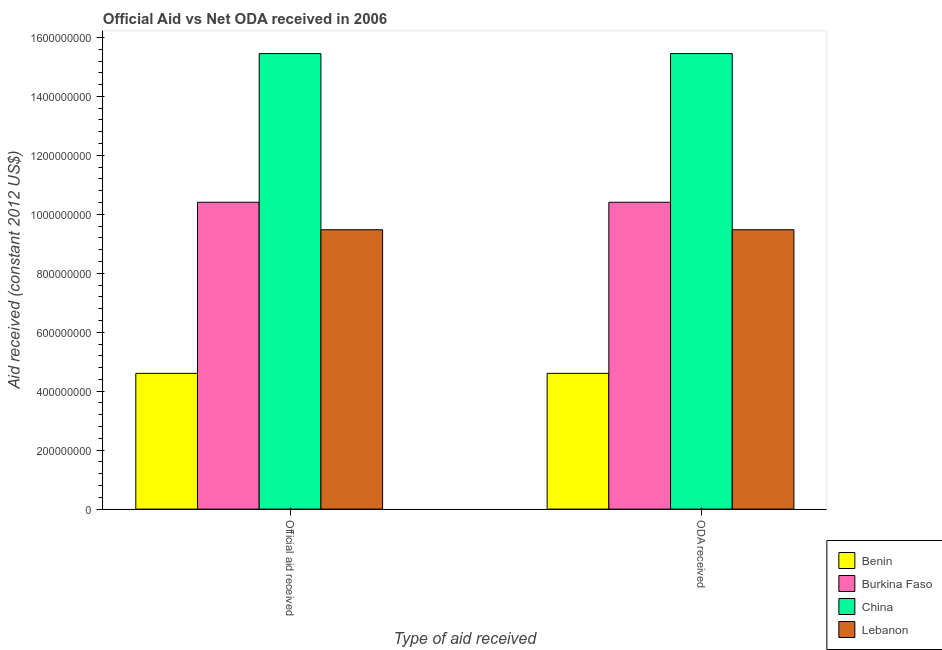How many different coloured bars are there?
Your response must be concise. 4. Are the number of bars per tick equal to the number of legend labels?
Keep it short and to the point. Yes. What is the label of the 1st group of bars from the left?
Your response must be concise. Official aid received. What is the official aid received in Lebanon?
Give a very brief answer. 9.48e+08. Across all countries, what is the maximum oda received?
Your response must be concise. 1.55e+09. Across all countries, what is the minimum oda received?
Give a very brief answer. 4.60e+08. In which country was the official aid received minimum?
Ensure brevity in your answer.  Benin. What is the total official aid received in the graph?
Your response must be concise. 3.99e+09. What is the difference between the official aid received in Benin and that in Lebanon?
Provide a succinct answer. -4.87e+08. What is the difference between the official aid received in Burkina Faso and the oda received in Lebanon?
Give a very brief answer. 9.31e+07. What is the average oda received per country?
Ensure brevity in your answer.  9.98e+08. What is the ratio of the oda received in Burkina Faso to that in Lebanon?
Offer a terse response. 1.1. In how many countries, is the official aid received greater than the average official aid received taken over all countries?
Your response must be concise. 2. What does the 1st bar from the left in ODA received represents?
Give a very brief answer. Benin. What does the 3rd bar from the right in ODA received represents?
Offer a very short reply. Burkina Faso. Does the graph contain any zero values?
Provide a short and direct response. No. Where does the legend appear in the graph?
Keep it short and to the point. Bottom right. How many legend labels are there?
Your answer should be very brief. 4. How are the legend labels stacked?
Ensure brevity in your answer.  Vertical. What is the title of the graph?
Offer a terse response. Official Aid vs Net ODA received in 2006 . What is the label or title of the X-axis?
Offer a terse response. Type of aid received. What is the label or title of the Y-axis?
Keep it short and to the point. Aid received (constant 2012 US$). What is the Aid received (constant 2012 US$) of Benin in Official aid received?
Ensure brevity in your answer.  4.60e+08. What is the Aid received (constant 2012 US$) of Burkina Faso in Official aid received?
Provide a short and direct response. 1.04e+09. What is the Aid received (constant 2012 US$) of China in Official aid received?
Offer a very short reply. 1.55e+09. What is the Aid received (constant 2012 US$) of Lebanon in Official aid received?
Provide a succinct answer. 9.48e+08. What is the Aid received (constant 2012 US$) in Benin in ODA received?
Your answer should be compact. 4.60e+08. What is the Aid received (constant 2012 US$) of Burkina Faso in ODA received?
Keep it short and to the point. 1.04e+09. What is the Aid received (constant 2012 US$) in China in ODA received?
Your answer should be very brief. 1.55e+09. What is the Aid received (constant 2012 US$) of Lebanon in ODA received?
Ensure brevity in your answer.  9.48e+08. Across all Type of aid received, what is the maximum Aid received (constant 2012 US$) in Benin?
Your response must be concise. 4.60e+08. Across all Type of aid received, what is the maximum Aid received (constant 2012 US$) in Burkina Faso?
Your response must be concise. 1.04e+09. Across all Type of aid received, what is the maximum Aid received (constant 2012 US$) of China?
Your answer should be very brief. 1.55e+09. Across all Type of aid received, what is the maximum Aid received (constant 2012 US$) in Lebanon?
Make the answer very short. 9.48e+08. Across all Type of aid received, what is the minimum Aid received (constant 2012 US$) in Benin?
Your answer should be very brief. 4.60e+08. Across all Type of aid received, what is the minimum Aid received (constant 2012 US$) in Burkina Faso?
Provide a succinct answer. 1.04e+09. Across all Type of aid received, what is the minimum Aid received (constant 2012 US$) in China?
Keep it short and to the point. 1.55e+09. Across all Type of aid received, what is the minimum Aid received (constant 2012 US$) of Lebanon?
Ensure brevity in your answer.  9.48e+08. What is the total Aid received (constant 2012 US$) in Benin in the graph?
Provide a succinct answer. 9.21e+08. What is the total Aid received (constant 2012 US$) of Burkina Faso in the graph?
Offer a terse response. 2.08e+09. What is the total Aid received (constant 2012 US$) of China in the graph?
Make the answer very short. 3.09e+09. What is the total Aid received (constant 2012 US$) of Lebanon in the graph?
Provide a short and direct response. 1.90e+09. What is the difference between the Aid received (constant 2012 US$) of Benin in Official aid received and that in ODA received?
Offer a terse response. 0. What is the difference between the Aid received (constant 2012 US$) in Benin in Official aid received and the Aid received (constant 2012 US$) in Burkina Faso in ODA received?
Keep it short and to the point. -5.80e+08. What is the difference between the Aid received (constant 2012 US$) of Benin in Official aid received and the Aid received (constant 2012 US$) of China in ODA received?
Your answer should be compact. -1.08e+09. What is the difference between the Aid received (constant 2012 US$) in Benin in Official aid received and the Aid received (constant 2012 US$) in Lebanon in ODA received?
Provide a succinct answer. -4.87e+08. What is the difference between the Aid received (constant 2012 US$) of Burkina Faso in Official aid received and the Aid received (constant 2012 US$) of China in ODA received?
Offer a terse response. -5.04e+08. What is the difference between the Aid received (constant 2012 US$) in Burkina Faso in Official aid received and the Aid received (constant 2012 US$) in Lebanon in ODA received?
Your answer should be compact. 9.31e+07. What is the difference between the Aid received (constant 2012 US$) in China in Official aid received and the Aid received (constant 2012 US$) in Lebanon in ODA received?
Ensure brevity in your answer.  5.97e+08. What is the average Aid received (constant 2012 US$) of Benin per Type of aid received?
Keep it short and to the point. 4.60e+08. What is the average Aid received (constant 2012 US$) in Burkina Faso per Type of aid received?
Provide a short and direct response. 1.04e+09. What is the average Aid received (constant 2012 US$) in China per Type of aid received?
Ensure brevity in your answer.  1.55e+09. What is the average Aid received (constant 2012 US$) in Lebanon per Type of aid received?
Provide a short and direct response. 9.48e+08. What is the difference between the Aid received (constant 2012 US$) of Benin and Aid received (constant 2012 US$) of Burkina Faso in Official aid received?
Offer a very short reply. -5.80e+08. What is the difference between the Aid received (constant 2012 US$) in Benin and Aid received (constant 2012 US$) in China in Official aid received?
Give a very brief answer. -1.08e+09. What is the difference between the Aid received (constant 2012 US$) in Benin and Aid received (constant 2012 US$) in Lebanon in Official aid received?
Your answer should be compact. -4.87e+08. What is the difference between the Aid received (constant 2012 US$) in Burkina Faso and Aid received (constant 2012 US$) in China in Official aid received?
Your answer should be very brief. -5.04e+08. What is the difference between the Aid received (constant 2012 US$) of Burkina Faso and Aid received (constant 2012 US$) of Lebanon in Official aid received?
Make the answer very short. 9.31e+07. What is the difference between the Aid received (constant 2012 US$) of China and Aid received (constant 2012 US$) of Lebanon in Official aid received?
Your response must be concise. 5.97e+08. What is the difference between the Aid received (constant 2012 US$) of Benin and Aid received (constant 2012 US$) of Burkina Faso in ODA received?
Provide a succinct answer. -5.80e+08. What is the difference between the Aid received (constant 2012 US$) in Benin and Aid received (constant 2012 US$) in China in ODA received?
Provide a short and direct response. -1.08e+09. What is the difference between the Aid received (constant 2012 US$) in Benin and Aid received (constant 2012 US$) in Lebanon in ODA received?
Give a very brief answer. -4.87e+08. What is the difference between the Aid received (constant 2012 US$) in Burkina Faso and Aid received (constant 2012 US$) in China in ODA received?
Keep it short and to the point. -5.04e+08. What is the difference between the Aid received (constant 2012 US$) of Burkina Faso and Aid received (constant 2012 US$) of Lebanon in ODA received?
Keep it short and to the point. 9.31e+07. What is the difference between the Aid received (constant 2012 US$) in China and Aid received (constant 2012 US$) in Lebanon in ODA received?
Provide a short and direct response. 5.97e+08. What is the ratio of the Aid received (constant 2012 US$) in Benin in Official aid received to that in ODA received?
Provide a succinct answer. 1. What is the ratio of the Aid received (constant 2012 US$) in Lebanon in Official aid received to that in ODA received?
Provide a short and direct response. 1. What is the difference between the highest and the second highest Aid received (constant 2012 US$) of China?
Your answer should be very brief. 0. What is the difference between the highest and the lowest Aid received (constant 2012 US$) of Benin?
Provide a short and direct response. 0. What is the difference between the highest and the lowest Aid received (constant 2012 US$) in China?
Offer a very short reply. 0. 